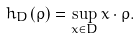<formula> <loc_0><loc_0><loc_500><loc_500>h _ { D } ( \rho ) = \sup _ { x \in D } x \cdot \rho .</formula> 